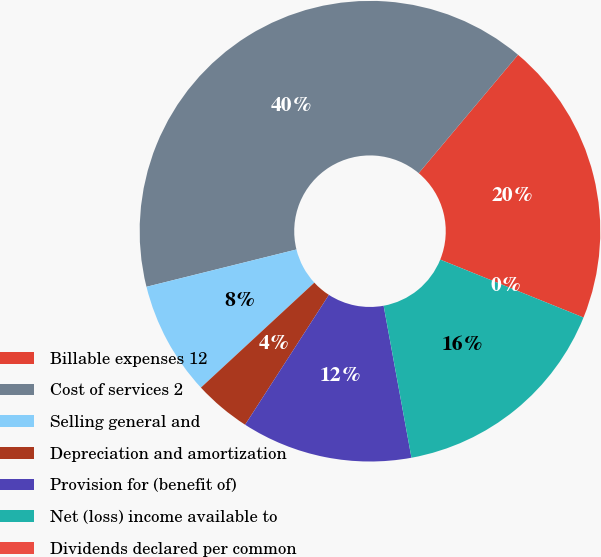Convert chart. <chart><loc_0><loc_0><loc_500><loc_500><pie_chart><fcel>Billable expenses 12<fcel>Cost of services 2<fcel>Selling general and<fcel>Depreciation and amortization<fcel>Provision for (benefit of)<fcel>Net (loss) income available to<fcel>Dividends declared per common<nl><fcel>20.0%<fcel>39.99%<fcel>8.0%<fcel>4.0%<fcel>12.0%<fcel>16.0%<fcel>0.0%<nl></chart> 